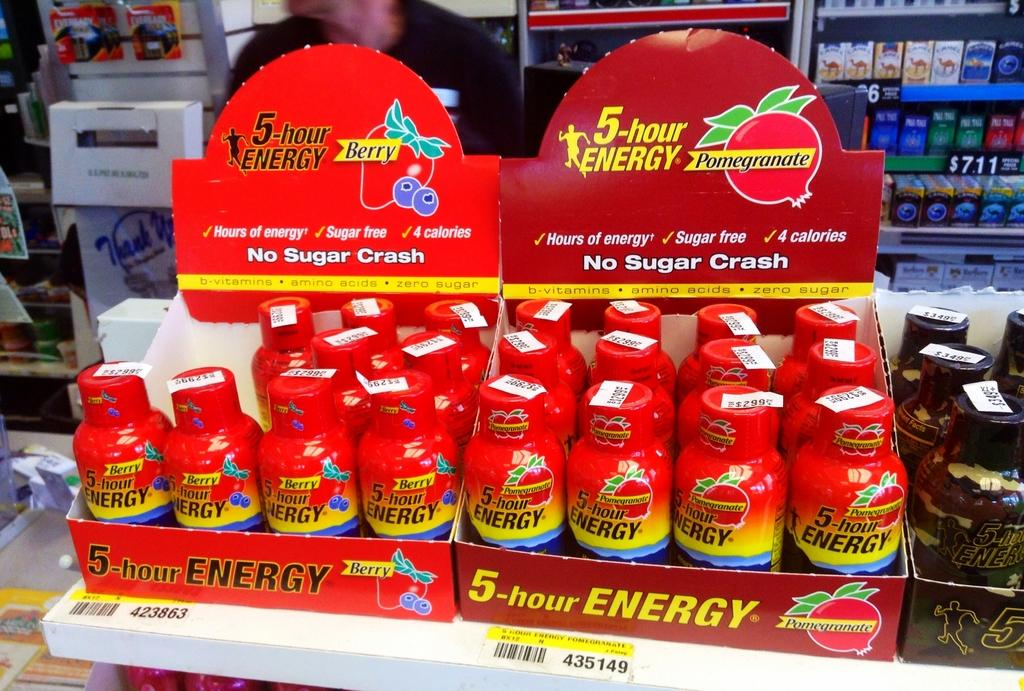<image>
Relay a brief, clear account of the picture shown. Three side by side displays of 5-hour Energy drinks. 